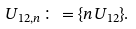<formula> <loc_0><loc_0><loc_500><loc_500>U _ { 1 2 , n } \colon = \{ n U _ { 1 2 } \} .</formula> 